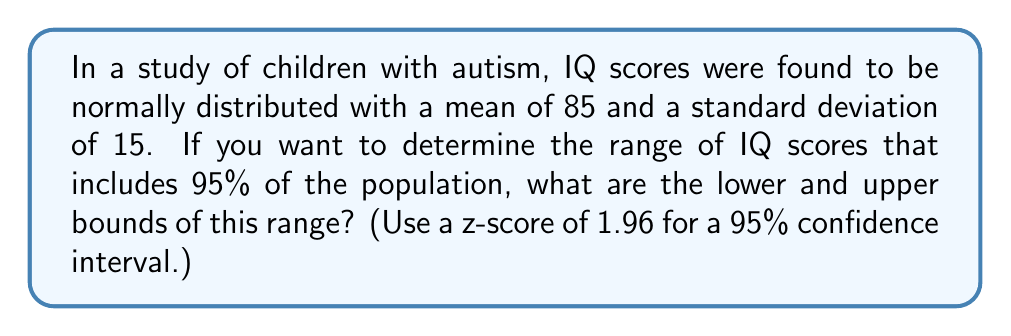Can you solve this math problem? To solve this problem, we'll follow these steps:

1) Recall the formula for a confidence interval in a normal distribution:
   $$\text{CI} = \mu \pm (z \times \sigma)$$
   where $\mu$ is the mean, $z$ is the z-score, and $\sigma$ is the standard deviation.

2) We're given:
   $\mu = 85$ (mean IQ score)
   $\sigma = 15$ (standard deviation)
   $z = 1.96$ (for 95% confidence interval)

3) Let's calculate the lower bound:
   $$\text{Lower bound} = 85 - (1.96 \times 15)$$
   $$= 85 - 29.4$$
   $$= 55.6$$

4) Now, let's calculate the upper bound:
   $$\text{Upper bound} = 85 + (1.96 \times 15)$$
   $$= 85 + 29.4$$
   $$= 114.4$$

5) Therefore, the range of IQ scores that includes 95% of the population is from 55.6 to 114.4.

6) Rounding to the nearest whole number (as IQ scores are typically reported as integers):
   Lower bound: 56
   Upper bound: 114
Answer: 56 to 114 